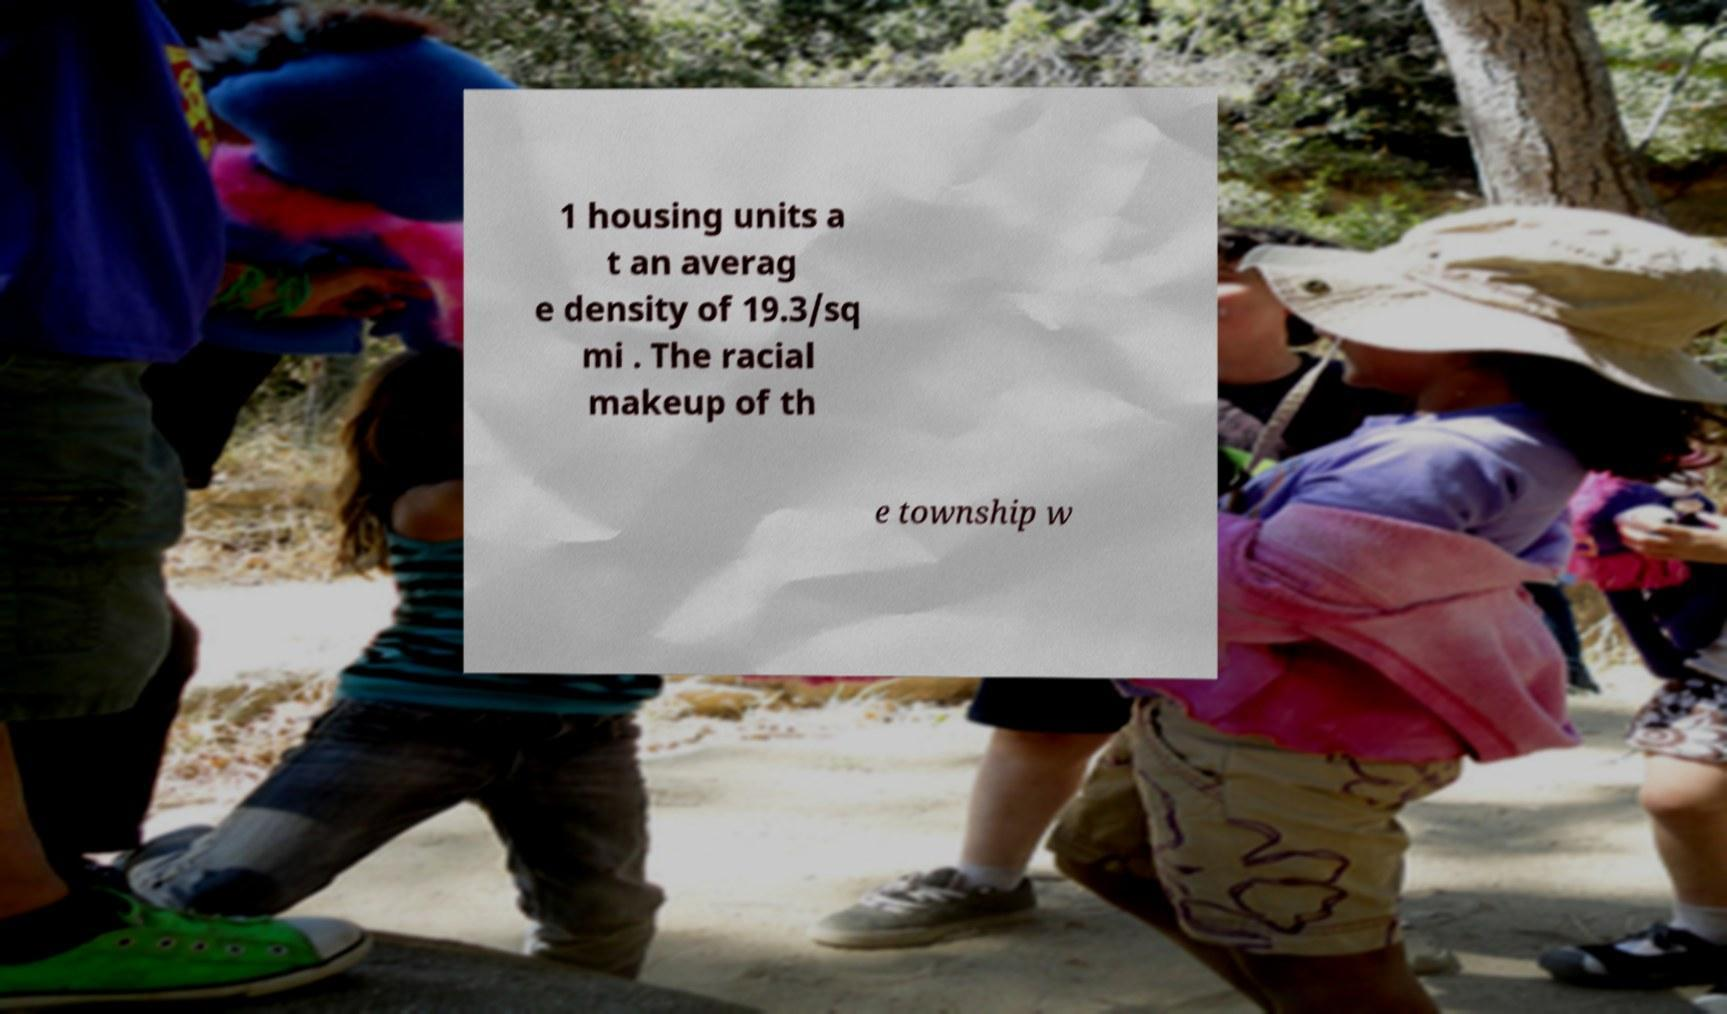Please identify and transcribe the text found in this image. 1 housing units a t an averag e density of 19.3/sq mi . The racial makeup of th e township w 